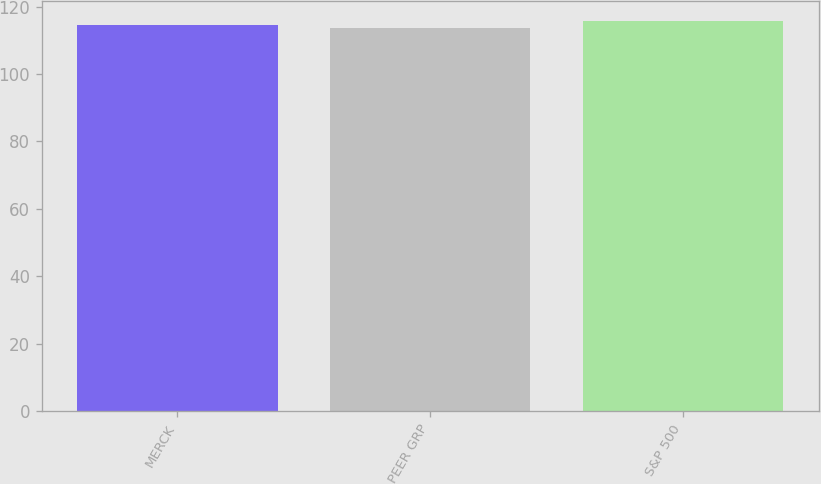Convert chart. <chart><loc_0><loc_0><loc_500><loc_500><bar_chart><fcel>MERCK<fcel>PEER GRP<fcel>S&P 500<nl><fcel>114.44<fcel>113.53<fcel>115.78<nl></chart> 